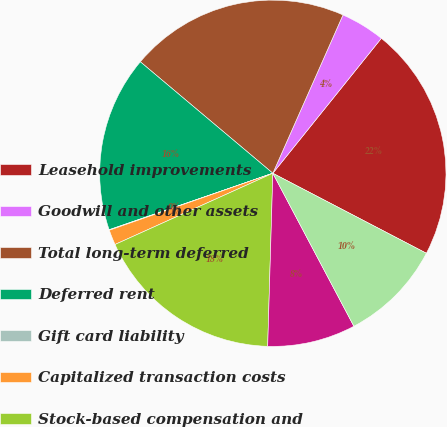Convert chart. <chart><loc_0><loc_0><loc_500><loc_500><pie_chart><fcel>Leasehold improvements<fcel>Goodwill and other assets<fcel>Total long-term deferred<fcel>Deferred rent<fcel>Gift card liability<fcel>Capitalized transaction costs<fcel>Stock-based compensation and<fcel>Foreign net operating loss<fcel>Valuation allowance<nl><fcel>21.87%<fcel>4.14%<fcel>20.51%<fcel>16.42%<fcel>0.05%<fcel>1.41%<fcel>17.78%<fcel>8.23%<fcel>9.6%<nl></chart> 